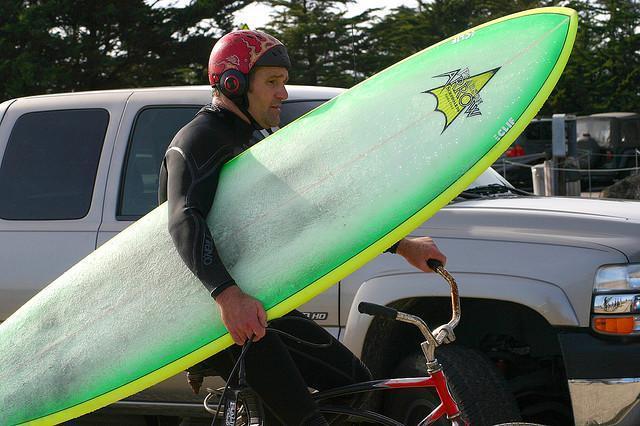How many numbers are on the clock tower?
Give a very brief answer. 0. 